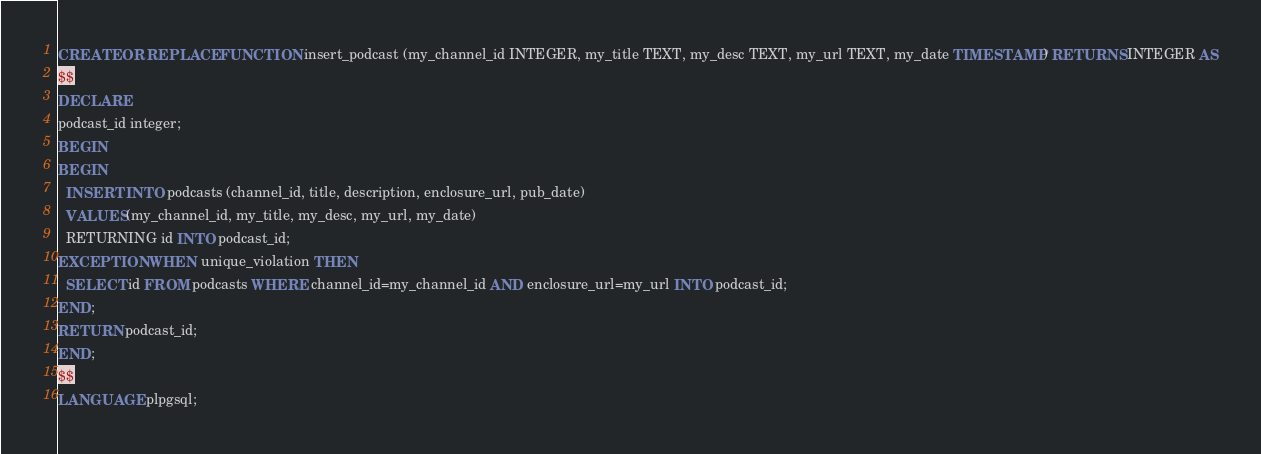Convert code to text. <code><loc_0><loc_0><loc_500><loc_500><_SQL_>CREATE OR REPLACE FUNCTION insert_podcast (my_channel_id INTEGER, my_title TEXT, my_desc TEXT, my_url TEXT, my_date TIMESTAMP) RETURNS INTEGER AS
$$
DECLARE
podcast_id integer;
BEGIN
BEGIN
  INSERT INTO podcasts (channel_id, title, description, enclosure_url, pub_date)
  VALUES(my_channel_id, my_title, my_desc, my_url, my_date)
  RETURNING id INTO podcast_id;
EXCEPTION WHEN unique_violation THEN
  SELECT id FROM podcasts WHERE channel_id=my_channel_id AND enclosure_url=my_url INTO podcast_id;
END;
RETURN podcast_id;
END;
$$
LANGUAGE plpgsql;
</code> 